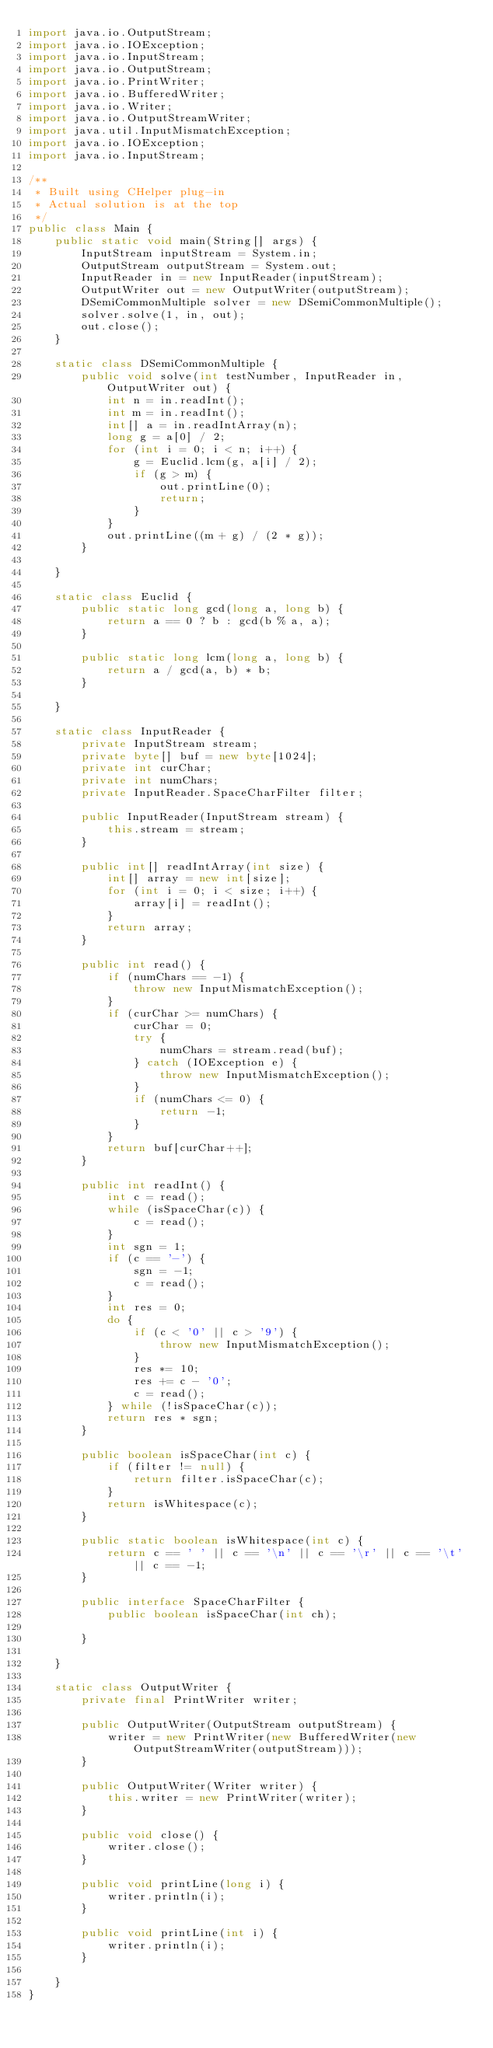<code> <loc_0><loc_0><loc_500><loc_500><_Java_>import java.io.OutputStream;
import java.io.IOException;
import java.io.InputStream;
import java.io.OutputStream;
import java.io.PrintWriter;
import java.io.BufferedWriter;
import java.io.Writer;
import java.io.OutputStreamWriter;
import java.util.InputMismatchException;
import java.io.IOException;
import java.io.InputStream;

/**
 * Built using CHelper plug-in
 * Actual solution is at the top
 */
public class Main {
    public static void main(String[] args) {
        InputStream inputStream = System.in;
        OutputStream outputStream = System.out;
        InputReader in = new InputReader(inputStream);
        OutputWriter out = new OutputWriter(outputStream);
        DSemiCommonMultiple solver = new DSemiCommonMultiple();
        solver.solve(1, in, out);
        out.close();
    }

    static class DSemiCommonMultiple {
        public void solve(int testNumber, InputReader in, OutputWriter out) {
            int n = in.readInt();
            int m = in.readInt();
            int[] a = in.readIntArray(n);
            long g = a[0] / 2;
            for (int i = 0; i < n; i++) {
                g = Euclid.lcm(g, a[i] / 2);
                if (g > m) {
                    out.printLine(0);
                    return;
                }
            }
            out.printLine((m + g) / (2 * g));
        }

    }

    static class Euclid {
        public static long gcd(long a, long b) {
            return a == 0 ? b : gcd(b % a, a);
        }

        public static long lcm(long a, long b) {
            return a / gcd(a, b) * b;
        }

    }

    static class InputReader {
        private InputStream stream;
        private byte[] buf = new byte[1024];
        private int curChar;
        private int numChars;
        private InputReader.SpaceCharFilter filter;

        public InputReader(InputStream stream) {
            this.stream = stream;
        }

        public int[] readIntArray(int size) {
            int[] array = new int[size];
            for (int i = 0; i < size; i++) {
                array[i] = readInt();
            }
            return array;
        }

        public int read() {
            if (numChars == -1) {
                throw new InputMismatchException();
            }
            if (curChar >= numChars) {
                curChar = 0;
                try {
                    numChars = stream.read(buf);
                } catch (IOException e) {
                    throw new InputMismatchException();
                }
                if (numChars <= 0) {
                    return -1;
                }
            }
            return buf[curChar++];
        }

        public int readInt() {
            int c = read();
            while (isSpaceChar(c)) {
                c = read();
            }
            int sgn = 1;
            if (c == '-') {
                sgn = -1;
                c = read();
            }
            int res = 0;
            do {
                if (c < '0' || c > '9') {
                    throw new InputMismatchException();
                }
                res *= 10;
                res += c - '0';
                c = read();
            } while (!isSpaceChar(c));
            return res * sgn;
        }

        public boolean isSpaceChar(int c) {
            if (filter != null) {
                return filter.isSpaceChar(c);
            }
            return isWhitespace(c);
        }

        public static boolean isWhitespace(int c) {
            return c == ' ' || c == '\n' || c == '\r' || c == '\t' || c == -1;
        }

        public interface SpaceCharFilter {
            public boolean isSpaceChar(int ch);

        }

    }

    static class OutputWriter {
        private final PrintWriter writer;

        public OutputWriter(OutputStream outputStream) {
            writer = new PrintWriter(new BufferedWriter(new OutputStreamWriter(outputStream)));
        }

        public OutputWriter(Writer writer) {
            this.writer = new PrintWriter(writer);
        }

        public void close() {
            writer.close();
        }

        public void printLine(long i) {
            writer.println(i);
        }

        public void printLine(int i) {
            writer.println(i);
        }

    }
}

</code> 